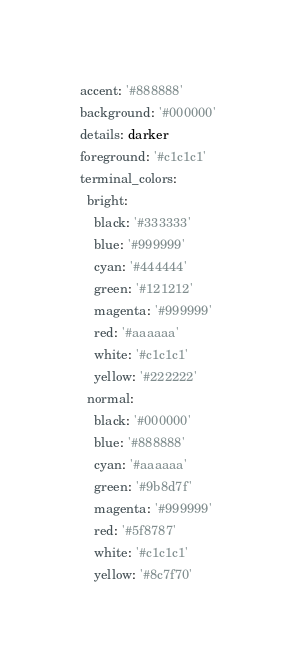<code> <loc_0><loc_0><loc_500><loc_500><_YAML_>
accent: '#888888'
background: '#000000'
details: darker
foreground: '#c1c1c1'
terminal_colors:
  bright:
    black: '#333333'
    blue: '#999999'
    cyan: '#444444'
    green: '#121212'
    magenta: '#999999'
    red: '#aaaaaa'
    white: '#c1c1c1'
    yellow: '#222222'
  normal:
    black: '#000000'
    blue: '#888888'
    cyan: '#aaaaaa'
    green: '#9b8d7f'
    magenta: '#999999'
    red: '#5f8787'
    white: '#c1c1c1'
    yellow: '#8c7f70'
</code> 